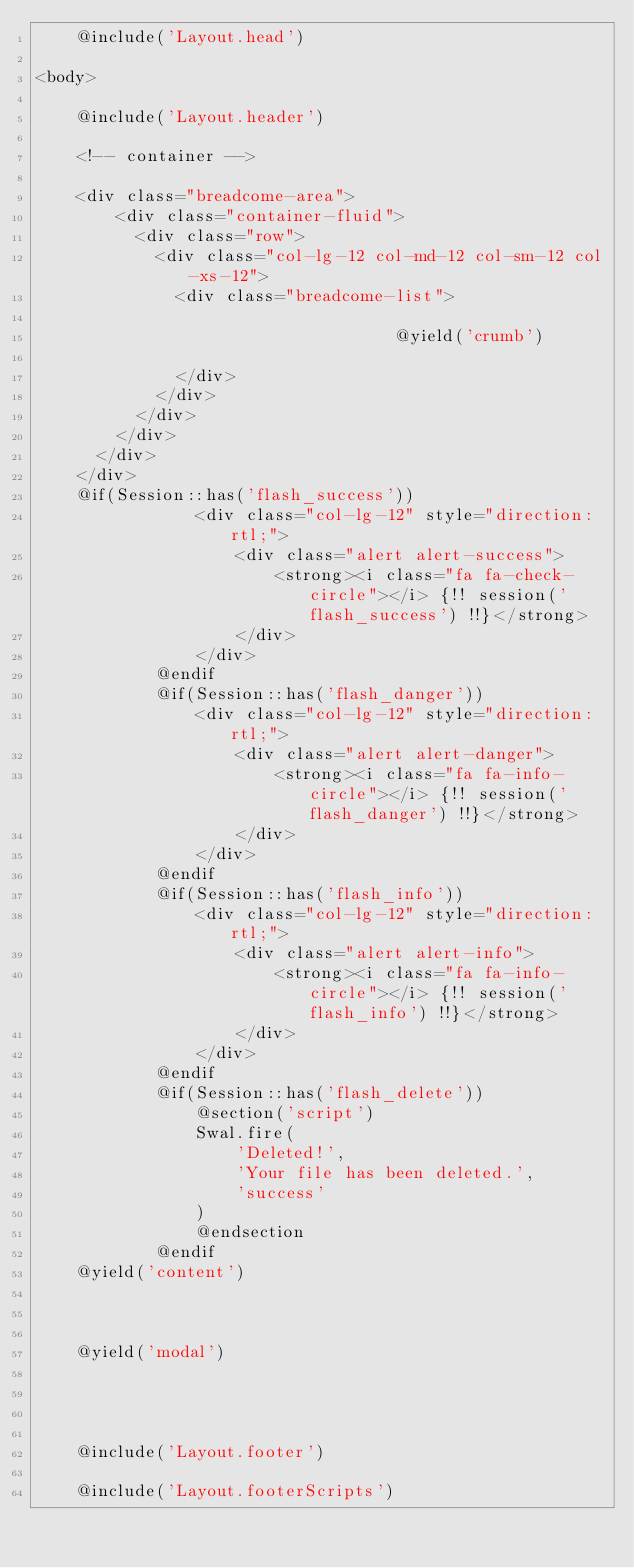<code> <loc_0><loc_0><loc_500><loc_500><_PHP_>    @include('Layout.head')

<body>

    @include('Layout.header')

    <!-- container -->

    <div class="breadcome-area">
				<div class="container-fluid">
					<div class="row">
						<div class="col-lg-12 col-md-12 col-sm-12 col-xs-12">
							<div class="breadcome-list">
								
                                    @yield('crumb')
								
							</div>
						</div>
					</div>
				</div>
			</div>
		</div>
    @if(Session::has('flash_success'))
                <div class="col-lg-12" style="direction: rtl;">
                    <div class="alert alert-success">
                        <strong><i class="fa fa-check-circle"></i> {!! session('flash_success') !!}</strong>
                    </div>
                </div>
            @endif
            @if(Session::has('flash_danger'))
                <div class="col-lg-12" style="direction: rtl;">
                    <div class="alert alert-danger">
                        <strong><i class="fa fa-info-circle"></i> {!! session('flash_danger') !!}</strong>
                    </div>
                </div>
            @endif
            @if(Session::has('flash_info'))
                <div class="col-lg-12" style="direction: rtl;">
                    <div class="alert alert-info">
                        <strong><i class="fa fa-info-circle"></i> {!! session('flash_info') !!}</strong>
                    </div>
                </div>
            @endif
            @if(Session::has('flash_delete'))
                @section('script')
                Swal.fire(
                    'Deleted!',
                    'Your file has been deleted.',
                    'success'
                )
                @endsection
            @endif
    @yield('content')



    @yield('modal')




    @include('Layout.footer')

    @include('Layout.footerScripts')</code> 